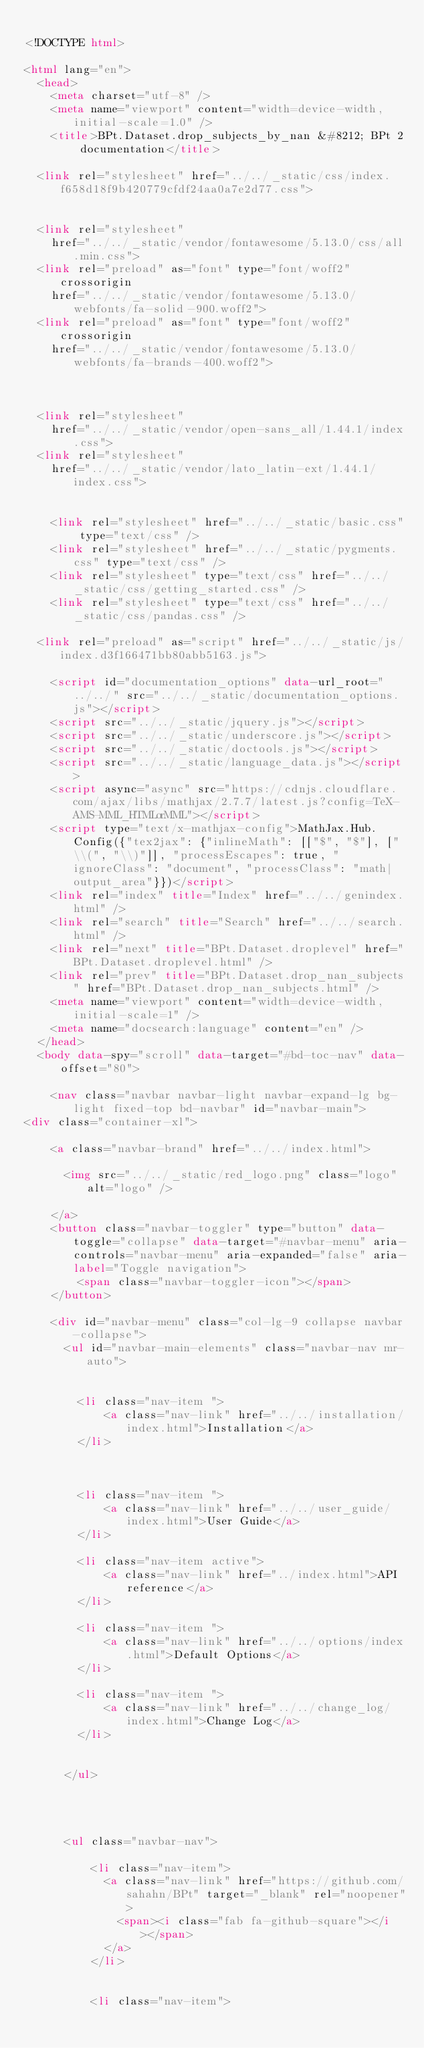<code> <loc_0><loc_0><loc_500><loc_500><_HTML_>
<!DOCTYPE html>

<html lang="en">
  <head>
    <meta charset="utf-8" />
    <meta name="viewport" content="width=device-width, initial-scale=1.0" />
    <title>BPt.Dataset.drop_subjects_by_nan &#8212; BPt 2 documentation</title>
    
  <link rel="stylesheet" href="../../_static/css/index.f658d18f9b420779cfdf24aa0a7e2d77.css">

    
  <link rel="stylesheet"
    href="../../_static/vendor/fontawesome/5.13.0/css/all.min.css">
  <link rel="preload" as="font" type="font/woff2" crossorigin
    href="../../_static/vendor/fontawesome/5.13.0/webfonts/fa-solid-900.woff2">
  <link rel="preload" as="font" type="font/woff2" crossorigin
    href="../../_static/vendor/fontawesome/5.13.0/webfonts/fa-brands-400.woff2">

    
      
  <link rel="stylesheet"
    href="../../_static/vendor/open-sans_all/1.44.1/index.css">
  <link rel="stylesheet"
    href="../../_static/vendor/lato_latin-ext/1.44.1/index.css">

    
    <link rel="stylesheet" href="../../_static/basic.css" type="text/css" />
    <link rel="stylesheet" href="../../_static/pygments.css" type="text/css" />
    <link rel="stylesheet" type="text/css" href="../../_static/css/getting_started.css" />
    <link rel="stylesheet" type="text/css" href="../../_static/css/pandas.css" />
    
  <link rel="preload" as="script" href="../../_static/js/index.d3f166471bb80abb5163.js">

    <script id="documentation_options" data-url_root="../../" src="../../_static/documentation_options.js"></script>
    <script src="../../_static/jquery.js"></script>
    <script src="../../_static/underscore.js"></script>
    <script src="../../_static/doctools.js"></script>
    <script src="../../_static/language_data.js"></script>
    <script async="async" src="https://cdnjs.cloudflare.com/ajax/libs/mathjax/2.7.7/latest.js?config=TeX-AMS-MML_HTMLorMML"></script>
    <script type="text/x-mathjax-config">MathJax.Hub.Config({"tex2jax": {"inlineMath": [["$", "$"], ["\\(", "\\)"]], "processEscapes": true, "ignoreClass": "document", "processClass": "math|output_area"}})</script>
    <link rel="index" title="Index" href="../../genindex.html" />
    <link rel="search" title="Search" href="../../search.html" />
    <link rel="next" title="BPt.Dataset.droplevel" href="BPt.Dataset.droplevel.html" />
    <link rel="prev" title="BPt.Dataset.drop_nan_subjects" href="BPt.Dataset.drop_nan_subjects.html" />
    <meta name="viewport" content="width=device-width, initial-scale=1" />
    <meta name="docsearch:language" content="en" />
  </head>
  <body data-spy="scroll" data-target="#bd-toc-nav" data-offset="80">
    
    <nav class="navbar navbar-light navbar-expand-lg bg-light fixed-top bd-navbar" id="navbar-main">
<div class="container-xl">

    <a class="navbar-brand" href="../../index.html">
    
      <img src="../../_static/red_logo.png" class="logo" alt="logo" />
    
    </a>
    <button class="navbar-toggler" type="button" data-toggle="collapse" data-target="#navbar-menu" aria-controls="navbar-menu" aria-expanded="false" aria-label="Toggle navigation">
        <span class="navbar-toggler-icon"></span>
    </button>

    <div id="navbar-menu" class="col-lg-9 collapse navbar-collapse">
      <ul id="navbar-main-elements" class="navbar-nav mr-auto">
        
        
        <li class="nav-item ">
            <a class="nav-link" href="../../installation/index.html">Installation</a>
        </li>
        
        
        
        <li class="nav-item ">
            <a class="nav-link" href="../../user_guide/index.html">User Guide</a>
        </li>
        
        <li class="nav-item active">
            <a class="nav-link" href="../index.html">API reference</a>
        </li>
        
        <li class="nav-item ">
            <a class="nav-link" href="../../options/index.html">Default Options</a>
        </li>
        
        <li class="nav-item ">
            <a class="nav-link" href="../../change_log/index.html">Change Log</a>
        </li>
        
        
      </ul>


      

      <ul class="navbar-nav">
        
          <li class="nav-item">
            <a class="nav-link" href="https://github.com/sahahn/BPt" target="_blank" rel="noopener">
              <span><i class="fab fa-github-square"></i></span>
            </a>
          </li>
        
        
          <li class="nav-item"></code> 